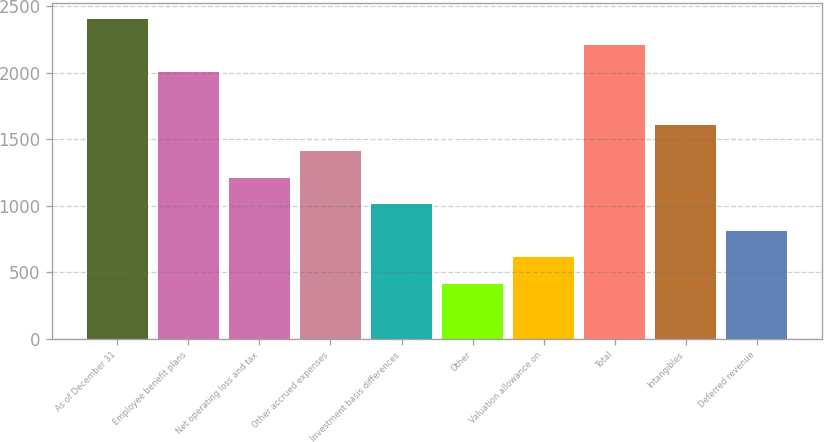Convert chart to OTSL. <chart><loc_0><loc_0><loc_500><loc_500><bar_chart><fcel>As of December 31<fcel>Employee benefit plans<fcel>Net operating loss and tax<fcel>Other accrued expenses<fcel>Investment basis differences<fcel>Other<fcel>Valuation allowance on<fcel>Total<fcel>Intangibles<fcel>Deferred revenue<nl><fcel>2406.6<fcel>2008<fcel>1210.8<fcel>1410.1<fcel>1011.5<fcel>413.6<fcel>612.9<fcel>2207.3<fcel>1609.4<fcel>812.2<nl></chart> 